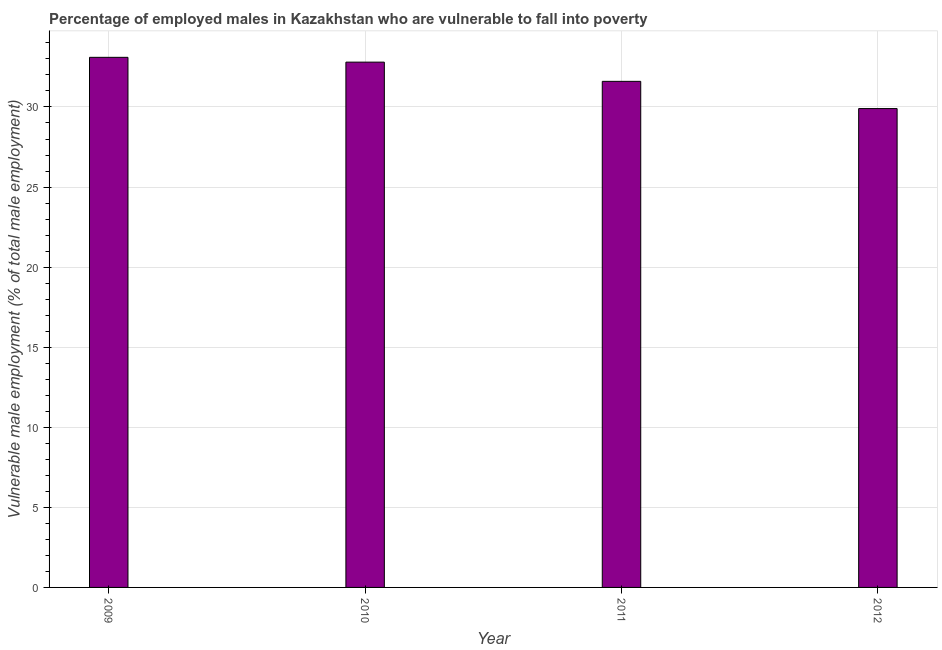What is the title of the graph?
Your answer should be compact. Percentage of employed males in Kazakhstan who are vulnerable to fall into poverty. What is the label or title of the Y-axis?
Offer a terse response. Vulnerable male employment (% of total male employment). What is the percentage of employed males who are vulnerable to fall into poverty in 2011?
Make the answer very short. 31.6. Across all years, what is the maximum percentage of employed males who are vulnerable to fall into poverty?
Ensure brevity in your answer.  33.1. Across all years, what is the minimum percentage of employed males who are vulnerable to fall into poverty?
Provide a short and direct response. 29.9. In which year was the percentage of employed males who are vulnerable to fall into poverty maximum?
Give a very brief answer. 2009. What is the sum of the percentage of employed males who are vulnerable to fall into poverty?
Offer a very short reply. 127.4. What is the difference between the percentage of employed males who are vulnerable to fall into poverty in 2009 and 2012?
Offer a terse response. 3.2. What is the average percentage of employed males who are vulnerable to fall into poverty per year?
Provide a succinct answer. 31.85. What is the median percentage of employed males who are vulnerable to fall into poverty?
Offer a very short reply. 32.2. What is the ratio of the percentage of employed males who are vulnerable to fall into poverty in 2009 to that in 2011?
Your response must be concise. 1.05. Is the difference between the percentage of employed males who are vulnerable to fall into poverty in 2011 and 2012 greater than the difference between any two years?
Provide a short and direct response. No. Is the sum of the percentage of employed males who are vulnerable to fall into poverty in 2009 and 2012 greater than the maximum percentage of employed males who are vulnerable to fall into poverty across all years?
Keep it short and to the point. Yes. How many years are there in the graph?
Provide a short and direct response. 4. What is the difference between two consecutive major ticks on the Y-axis?
Offer a terse response. 5. Are the values on the major ticks of Y-axis written in scientific E-notation?
Offer a terse response. No. What is the Vulnerable male employment (% of total male employment) in 2009?
Ensure brevity in your answer.  33.1. What is the Vulnerable male employment (% of total male employment) in 2010?
Make the answer very short. 32.8. What is the Vulnerable male employment (% of total male employment) in 2011?
Your response must be concise. 31.6. What is the Vulnerable male employment (% of total male employment) in 2012?
Provide a short and direct response. 29.9. What is the difference between the Vulnerable male employment (% of total male employment) in 2009 and 2010?
Provide a succinct answer. 0.3. What is the difference between the Vulnerable male employment (% of total male employment) in 2009 and 2012?
Keep it short and to the point. 3.2. What is the difference between the Vulnerable male employment (% of total male employment) in 2010 and 2011?
Provide a short and direct response. 1.2. What is the ratio of the Vulnerable male employment (% of total male employment) in 2009 to that in 2011?
Your answer should be compact. 1.05. What is the ratio of the Vulnerable male employment (% of total male employment) in 2009 to that in 2012?
Your response must be concise. 1.11. What is the ratio of the Vulnerable male employment (% of total male employment) in 2010 to that in 2011?
Give a very brief answer. 1.04. What is the ratio of the Vulnerable male employment (% of total male employment) in 2010 to that in 2012?
Ensure brevity in your answer.  1.1. What is the ratio of the Vulnerable male employment (% of total male employment) in 2011 to that in 2012?
Provide a succinct answer. 1.06. 